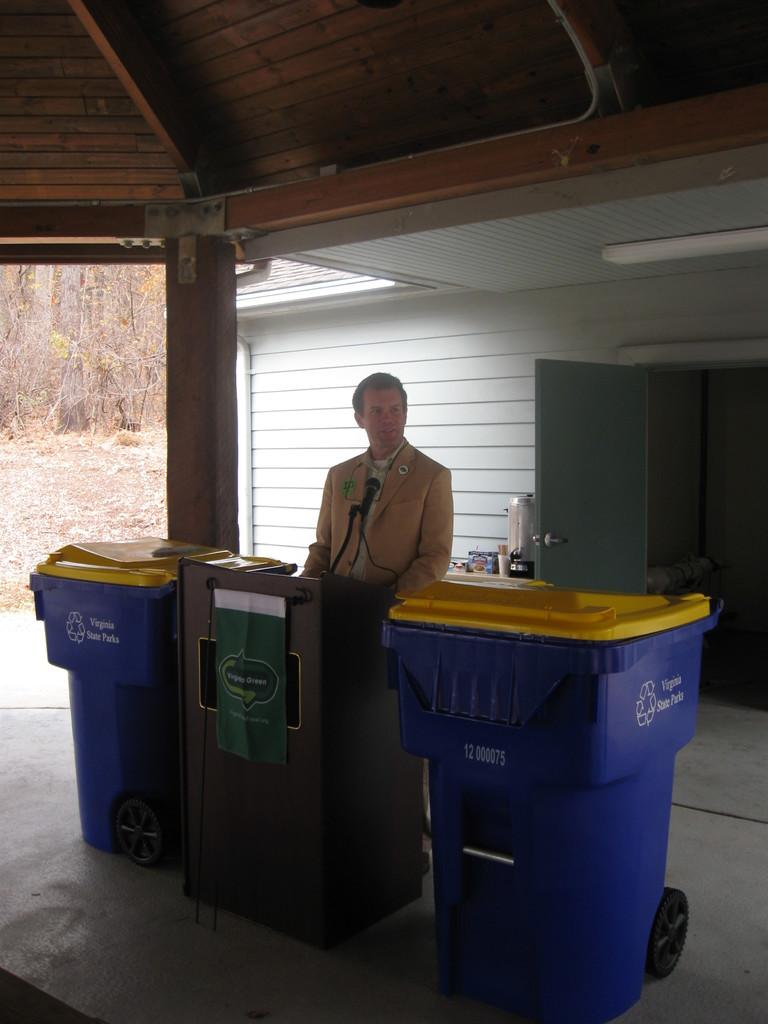<image>
Present a compact description of the photo's key features. A man standing between two Virginia State Park trash cans. 